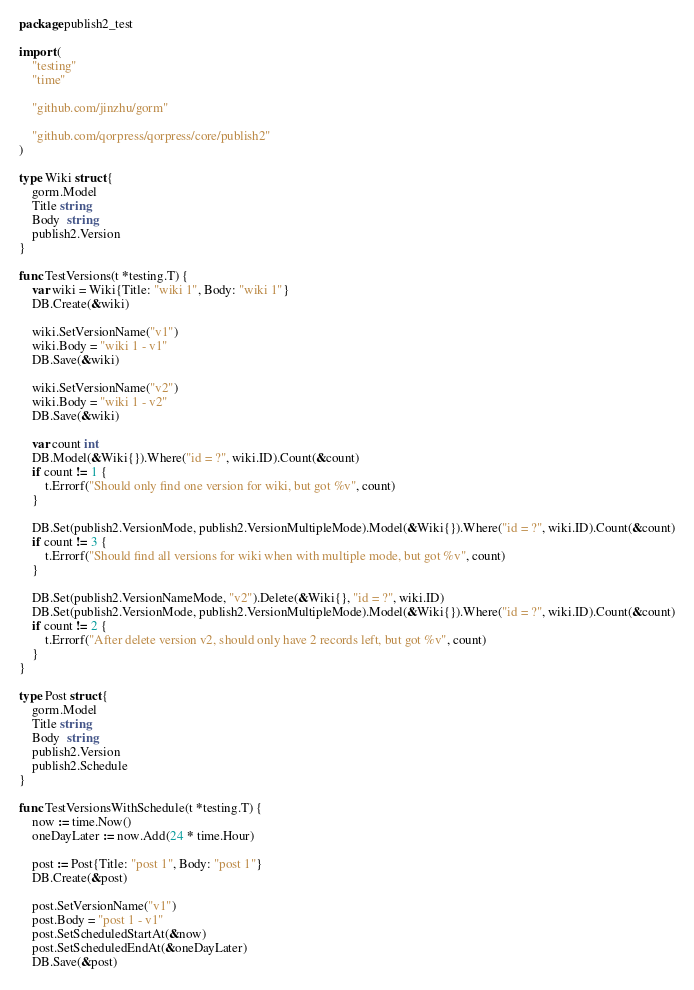<code> <loc_0><loc_0><loc_500><loc_500><_Go_>package publish2_test

import (
	"testing"
	"time"

	"github.com/jinzhu/gorm"

	"github.com/qorpress/qorpress/core/publish2"
)

type Wiki struct {
	gorm.Model
	Title string
	Body  string
	publish2.Version
}

func TestVersions(t *testing.T) {
	var wiki = Wiki{Title: "wiki 1", Body: "wiki 1"}
	DB.Create(&wiki)

	wiki.SetVersionName("v1")
	wiki.Body = "wiki 1 - v1"
	DB.Save(&wiki)

	wiki.SetVersionName("v2")
	wiki.Body = "wiki 1 - v2"
	DB.Save(&wiki)

	var count int
	DB.Model(&Wiki{}).Where("id = ?", wiki.ID).Count(&count)
	if count != 1 {
		t.Errorf("Should only find one version for wiki, but got %v", count)
	}

	DB.Set(publish2.VersionMode, publish2.VersionMultipleMode).Model(&Wiki{}).Where("id = ?", wiki.ID).Count(&count)
	if count != 3 {
		t.Errorf("Should find all versions for wiki when with multiple mode, but got %v", count)
	}

	DB.Set(publish2.VersionNameMode, "v2").Delete(&Wiki{}, "id = ?", wiki.ID)
	DB.Set(publish2.VersionMode, publish2.VersionMultipleMode).Model(&Wiki{}).Where("id = ?", wiki.ID).Count(&count)
	if count != 2 {
		t.Errorf("After delete version v2, should only have 2 records left, but got %v", count)
	}
}

type Post struct {
	gorm.Model
	Title string
	Body  string
	publish2.Version
	publish2.Schedule
}

func TestVersionsWithSchedule(t *testing.T) {
	now := time.Now()
	oneDayLater := now.Add(24 * time.Hour)

	post := Post{Title: "post 1", Body: "post 1"}
	DB.Create(&post)

	post.SetVersionName("v1")
	post.Body = "post 1 - v1"
	post.SetScheduledStartAt(&now)
	post.SetScheduledEndAt(&oneDayLater)
	DB.Save(&post)
</code> 